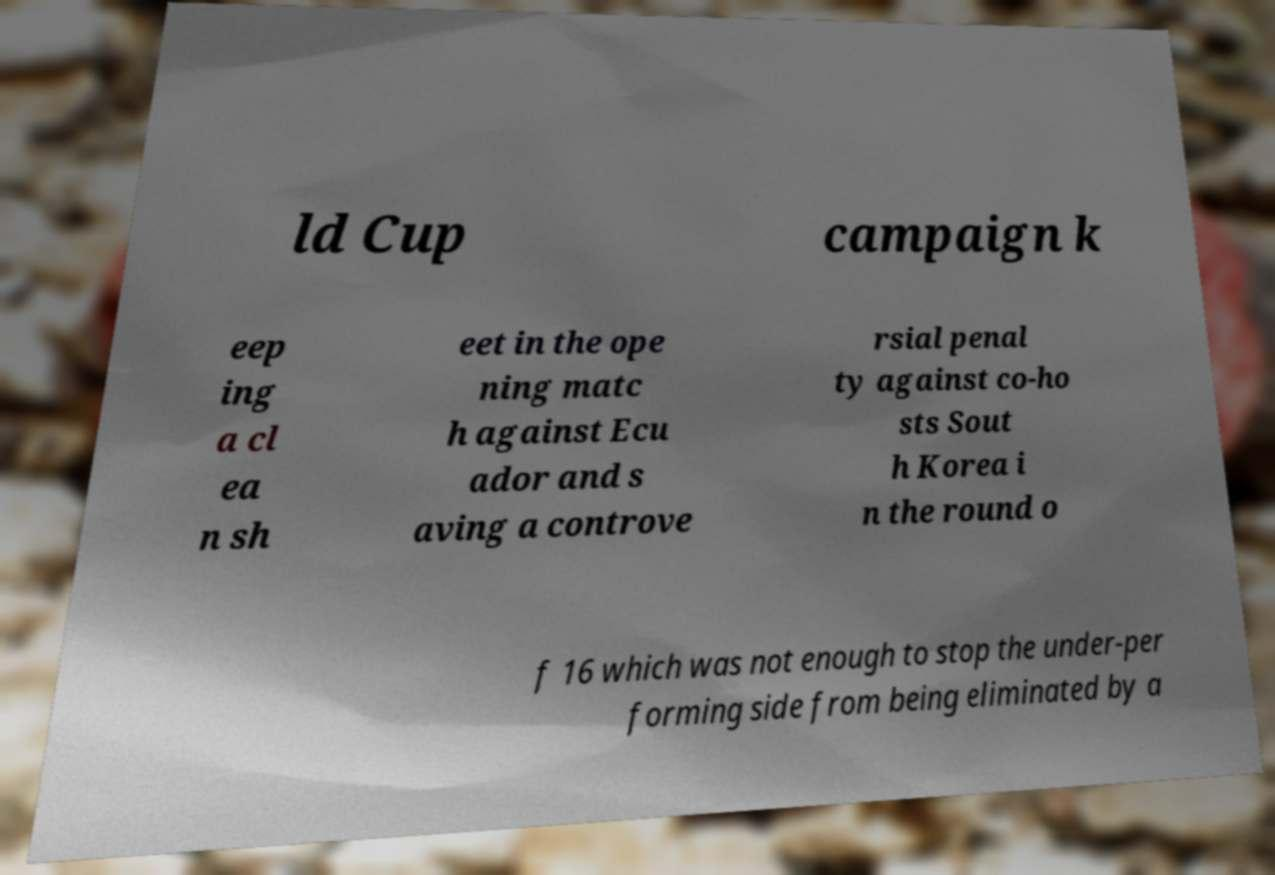What messages or text are displayed in this image? I need them in a readable, typed format. ld Cup campaign k eep ing a cl ea n sh eet in the ope ning matc h against Ecu ador and s aving a controve rsial penal ty against co-ho sts Sout h Korea i n the round o f 16 which was not enough to stop the under-per forming side from being eliminated by a 